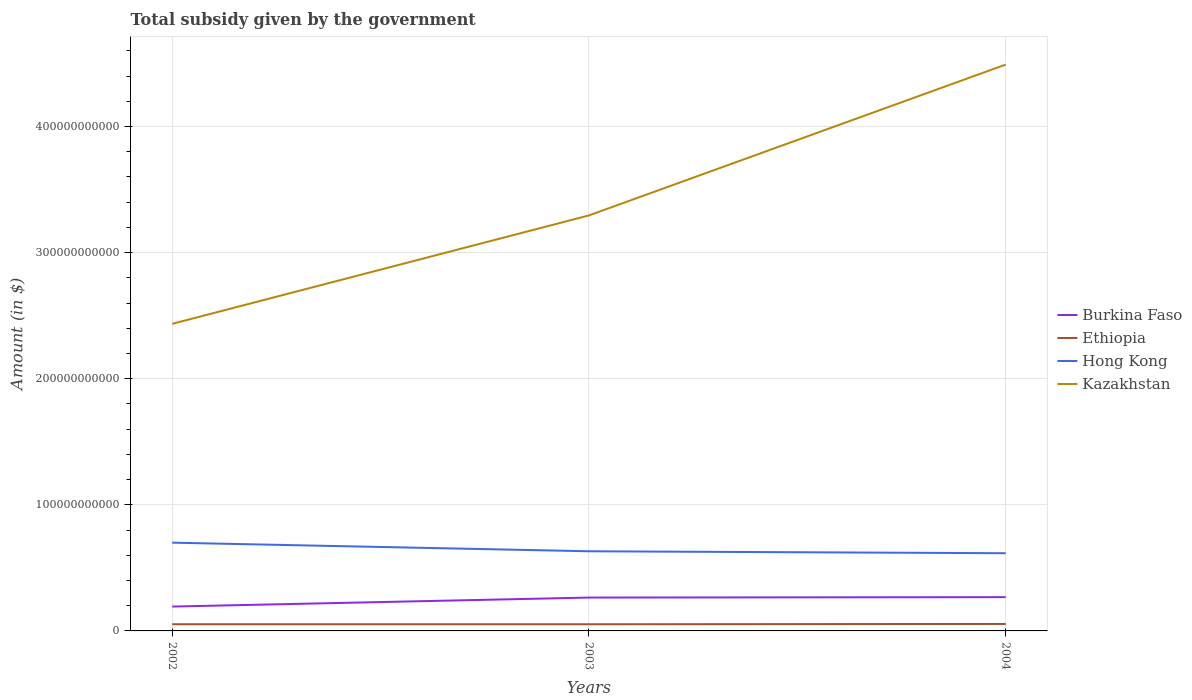Across all years, what is the maximum total revenue collected by the government in Burkina Faso?
Provide a succinct answer. 1.93e+1. What is the total total revenue collected by the government in Kazakhstan in the graph?
Your response must be concise. -2.06e+11. What is the difference between the highest and the second highest total revenue collected by the government in Hong Kong?
Your answer should be very brief. 8.37e+09. Is the total revenue collected by the government in Hong Kong strictly greater than the total revenue collected by the government in Burkina Faso over the years?
Ensure brevity in your answer.  No. What is the difference between two consecutive major ticks on the Y-axis?
Ensure brevity in your answer.  1.00e+11. Are the values on the major ticks of Y-axis written in scientific E-notation?
Give a very brief answer. No. Does the graph contain any zero values?
Ensure brevity in your answer.  No. Does the graph contain grids?
Provide a succinct answer. Yes. How many legend labels are there?
Provide a short and direct response. 4. What is the title of the graph?
Give a very brief answer. Total subsidy given by the government. What is the label or title of the Y-axis?
Your response must be concise. Amount (in $). What is the Amount (in $) in Burkina Faso in 2002?
Your answer should be compact. 1.93e+1. What is the Amount (in $) in Ethiopia in 2002?
Provide a succinct answer. 5.29e+09. What is the Amount (in $) of Hong Kong in 2002?
Provide a short and direct response. 7.00e+1. What is the Amount (in $) of Kazakhstan in 2002?
Make the answer very short. 2.44e+11. What is the Amount (in $) in Burkina Faso in 2003?
Your answer should be very brief. 2.65e+1. What is the Amount (in $) of Ethiopia in 2003?
Keep it short and to the point. 5.28e+09. What is the Amount (in $) of Hong Kong in 2003?
Make the answer very short. 6.32e+1. What is the Amount (in $) of Kazakhstan in 2003?
Provide a short and direct response. 3.29e+11. What is the Amount (in $) of Burkina Faso in 2004?
Your response must be concise. 2.68e+1. What is the Amount (in $) of Ethiopia in 2004?
Offer a terse response. 5.53e+09. What is the Amount (in $) of Hong Kong in 2004?
Your response must be concise. 6.16e+1. What is the Amount (in $) of Kazakhstan in 2004?
Make the answer very short. 4.49e+11. Across all years, what is the maximum Amount (in $) of Burkina Faso?
Your response must be concise. 2.68e+1. Across all years, what is the maximum Amount (in $) in Ethiopia?
Offer a terse response. 5.53e+09. Across all years, what is the maximum Amount (in $) of Hong Kong?
Offer a very short reply. 7.00e+1. Across all years, what is the maximum Amount (in $) in Kazakhstan?
Provide a short and direct response. 4.49e+11. Across all years, what is the minimum Amount (in $) of Burkina Faso?
Ensure brevity in your answer.  1.93e+1. Across all years, what is the minimum Amount (in $) in Ethiopia?
Provide a succinct answer. 5.28e+09. Across all years, what is the minimum Amount (in $) of Hong Kong?
Keep it short and to the point. 6.16e+1. Across all years, what is the minimum Amount (in $) of Kazakhstan?
Your response must be concise. 2.44e+11. What is the total Amount (in $) in Burkina Faso in the graph?
Your answer should be very brief. 7.26e+1. What is the total Amount (in $) of Ethiopia in the graph?
Your response must be concise. 1.61e+1. What is the total Amount (in $) of Hong Kong in the graph?
Make the answer very short. 1.95e+11. What is the total Amount (in $) in Kazakhstan in the graph?
Provide a succinct answer. 1.02e+12. What is the difference between the Amount (in $) of Burkina Faso in 2002 and that in 2003?
Your answer should be compact. -7.14e+09. What is the difference between the Amount (in $) of Ethiopia in 2002 and that in 2003?
Ensure brevity in your answer.  8.30e+06. What is the difference between the Amount (in $) of Hong Kong in 2002 and that in 2003?
Offer a very short reply. 6.82e+09. What is the difference between the Amount (in $) of Kazakhstan in 2002 and that in 2003?
Your response must be concise. -8.60e+1. What is the difference between the Amount (in $) in Burkina Faso in 2002 and that in 2004?
Provide a succinct answer. -7.47e+09. What is the difference between the Amount (in $) of Ethiopia in 2002 and that in 2004?
Provide a short and direct response. -2.40e+08. What is the difference between the Amount (in $) of Hong Kong in 2002 and that in 2004?
Make the answer very short. 8.37e+09. What is the difference between the Amount (in $) of Kazakhstan in 2002 and that in 2004?
Provide a short and direct response. -2.06e+11. What is the difference between the Amount (in $) of Burkina Faso in 2003 and that in 2004?
Offer a very short reply. -3.29e+08. What is the difference between the Amount (in $) of Ethiopia in 2003 and that in 2004?
Keep it short and to the point. -2.48e+08. What is the difference between the Amount (in $) in Hong Kong in 2003 and that in 2004?
Offer a terse response. 1.55e+09. What is the difference between the Amount (in $) in Kazakhstan in 2003 and that in 2004?
Give a very brief answer. -1.20e+11. What is the difference between the Amount (in $) of Burkina Faso in 2002 and the Amount (in $) of Ethiopia in 2003?
Provide a short and direct response. 1.40e+1. What is the difference between the Amount (in $) of Burkina Faso in 2002 and the Amount (in $) of Hong Kong in 2003?
Give a very brief answer. -4.39e+1. What is the difference between the Amount (in $) in Burkina Faso in 2002 and the Amount (in $) in Kazakhstan in 2003?
Offer a very short reply. -3.10e+11. What is the difference between the Amount (in $) of Ethiopia in 2002 and the Amount (in $) of Hong Kong in 2003?
Keep it short and to the point. -5.79e+1. What is the difference between the Amount (in $) in Ethiopia in 2002 and the Amount (in $) in Kazakhstan in 2003?
Offer a very short reply. -3.24e+11. What is the difference between the Amount (in $) in Hong Kong in 2002 and the Amount (in $) in Kazakhstan in 2003?
Provide a succinct answer. -2.60e+11. What is the difference between the Amount (in $) of Burkina Faso in 2002 and the Amount (in $) of Ethiopia in 2004?
Keep it short and to the point. 1.38e+1. What is the difference between the Amount (in $) in Burkina Faso in 2002 and the Amount (in $) in Hong Kong in 2004?
Provide a short and direct response. -4.23e+1. What is the difference between the Amount (in $) in Burkina Faso in 2002 and the Amount (in $) in Kazakhstan in 2004?
Your answer should be compact. -4.30e+11. What is the difference between the Amount (in $) in Ethiopia in 2002 and the Amount (in $) in Hong Kong in 2004?
Offer a terse response. -5.63e+1. What is the difference between the Amount (in $) of Ethiopia in 2002 and the Amount (in $) of Kazakhstan in 2004?
Your answer should be very brief. -4.44e+11. What is the difference between the Amount (in $) of Hong Kong in 2002 and the Amount (in $) of Kazakhstan in 2004?
Ensure brevity in your answer.  -3.79e+11. What is the difference between the Amount (in $) in Burkina Faso in 2003 and the Amount (in $) in Ethiopia in 2004?
Offer a very short reply. 2.09e+1. What is the difference between the Amount (in $) in Burkina Faso in 2003 and the Amount (in $) in Hong Kong in 2004?
Offer a terse response. -3.52e+1. What is the difference between the Amount (in $) of Burkina Faso in 2003 and the Amount (in $) of Kazakhstan in 2004?
Your response must be concise. -4.23e+11. What is the difference between the Amount (in $) in Ethiopia in 2003 and the Amount (in $) in Hong Kong in 2004?
Your response must be concise. -5.63e+1. What is the difference between the Amount (in $) of Ethiopia in 2003 and the Amount (in $) of Kazakhstan in 2004?
Offer a very short reply. -4.44e+11. What is the difference between the Amount (in $) of Hong Kong in 2003 and the Amount (in $) of Kazakhstan in 2004?
Provide a succinct answer. -3.86e+11. What is the average Amount (in $) in Burkina Faso per year?
Provide a succinct answer. 2.42e+1. What is the average Amount (in $) in Ethiopia per year?
Give a very brief answer. 5.37e+09. What is the average Amount (in $) in Hong Kong per year?
Your answer should be very brief. 6.49e+1. What is the average Amount (in $) of Kazakhstan per year?
Make the answer very short. 3.41e+11. In the year 2002, what is the difference between the Amount (in $) in Burkina Faso and Amount (in $) in Ethiopia?
Offer a terse response. 1.40e+1. In the year 2002, what is the difference between the Amount (in $) in Burkina Faso and Amount (in $) in Hong Kong?
Make the answer very short. -5.07e+1. In the year 2002, what is the difference between the Amount (in $) in Burkina Faso and Amount (in $) in Kazakhstan?
Ensure brevity in your answer.  -2.24e+11. In the year 2002, what is the difference between the Amount (in $) in Ethiopia and Amount (in $) in Hong Kong?
Provide a succinct answer. -6.47e+1. In the year 2002, what is the difference between the Amount (in $) of Ethiopia and Amount (in $) of Kazakhstan?
Offer a terse response. -2.38e+11. In the year 2002, what is the difference between the Amount (in $) in Hong Kong and Amount (in $) in Kazakhstan?
Your answer should be compact. -1.74e+11. In the year 2003, what is the difference between the Amount (in $) in Burkina Faso and Amount (in $) in Ethiopia?
Make the answer very short. 2.12e+1. In the year 2003, what is the difference between the Amount (in $) of Burkina Faso and Amount (in $) of Hong Kong?
Keep it short and to the point. -3.67e+1. In the year 2003, what is the difference between the Amount (in $) in Burkina Faso and Amount (in $) in Kazakhstan?
Provide a short and direct response. -3.03e+11. In the year 2003, what is the difference between the Amount (in $) in Ethiopia and Amount (in $) in Hong Kong?
Provide a succinct answer. -5.79e+1. In the year 2003, what is the difference between the Amount (in $) in Ethiopia and Amount (in $) in Kazakhstan?
Provide a succinct answer. -3.24e+11. In the year 2003, what is the difference between the Amount (in $) in Hong Kong and Amount (in $) in Kazakhstan?
Give a very brief answer. -2.66e+11. In the year 2004, what is the difference between the Amount (in $) in Burkina Faso and Amount (in $) in Ethiopia?
Ensure brevity in your answer.  2.13e+1. In the year 2004, what is the difference between the Amount (in $) of Burkina Faso and Amount (in $) of Hong Kong?
Provide a short and direct response. -3.48e+1. In the year 2004, what is the difference between the Amount (in $) of Burkina Faso and Amount (in $) of Kazakhstan?
Your answer should be compact. -4.22e+11. In the year 2004, what is the difference between the Amount (in $) in Ethiopia and Amount (in $) in Hong Kong?
Give a very brief answer. -5.61e+1. In the year 2004, what is the difference between the Amount (in $) of Ethiopia and Amount (in $) of Kazakhstan?
Your answer should be compact. -4.44e+11. In the year 2004, what is the difference between the Amount (in $) in Hong Kong and Amount (in $) in Kazakhstan?
Give a very brief answer. -3.88e+11. What is the ratio of the Amount (in $) of Burkina Faso in 2002 to that in 2003?
Provide a short and direct response. 0.73. What is the ratio of the Amount (in $) in Hong Kong in 2002 to that in 2003?
Keep it short and to the point. 1.11. What is the ratio of the Amount (in $) of Kazakhstan in 2002 to that in 2003?
Your answer should be very brief. 0.74. What is the ratio of the Amount (in $) in Burkina Faso in 2002 to that in 2004?
Make the answer very short. 0.72. What is the ratio of the Amount (in $) of Ethiopia in 2002 to that in 2004?
Your answer should be very brief. 0.96. What is the ratio of the Amount (in $) in Hong Kong in 2002 to that in 2004?
Keep it short and to the point. 1.14. What is the ratio of the Amount (in $) in Kazakhstan in 2002 to that in 2004?
Provide a short and direct response. 0.54. What is the ratio of the Amount (in $) in Burkina Faso in 2003 to that in 2004?
Your response must be concise. 0.99. What is the ratio of the Amount (in $) in Ethiopia in 2003 to that in 2004?
Make the answer very short. 0.96. What is the ratio of the Amount (in $) of Hong Kong in 2003 to that in 2004?
Keep it short and to the point. 1.03. What is the ratio of the Amount (in $) of Kazakhstan in 2003 to that in 2004?
Your answer should be compact. 0.73. What is the difference between the highest and the second highest Amount (in $) in Burkina Faso?
Provide a short and direct response. 3.29e+08. What is the difference between the highest and the second highest Amount (in $) of Ethiopia?
Offer a very short reply. 2.40e+08. What is the difference between the highest and the second highest Amount (in $) in Hong Kong?
Offer a terse response. 6.82e+09. What is the difference between the highest and the second highest Amount (in $) of Kazakhstan?
Your response must be concise. 1.20e+11. What is the difference between the highest and the lowest Amount (in $) in Burkina Faso?
Provide a short and direct response. 7.47e+09. What is the difference between the highest and the lowest Amount (in $) of Ethiopia?
Offer a very short reply. 2.48e+08. What is the difference between the highest and the lowest Amount (in $) in Hong Kong?
Offer a terse response. 8.37e+09. What is the difference between the highest and the lowest Amount (in $) of Kazakhstan?
Your answer should be compact. 2.06e+11. 